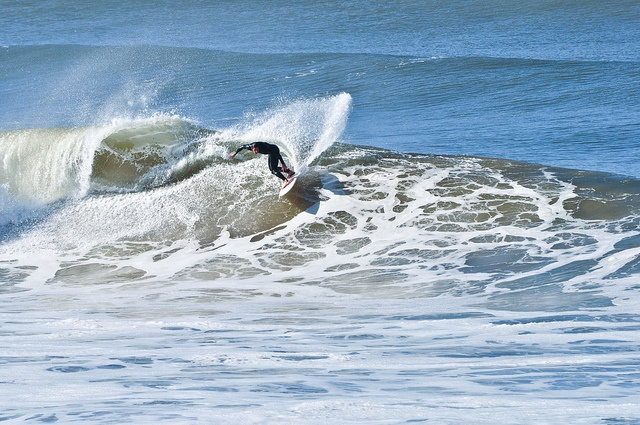Describe the objects in this image and their specific colors. I can see people in gray, black, darkgray, and lightgray tones and surfboard in gray, white, and darkgray tones in this image. 